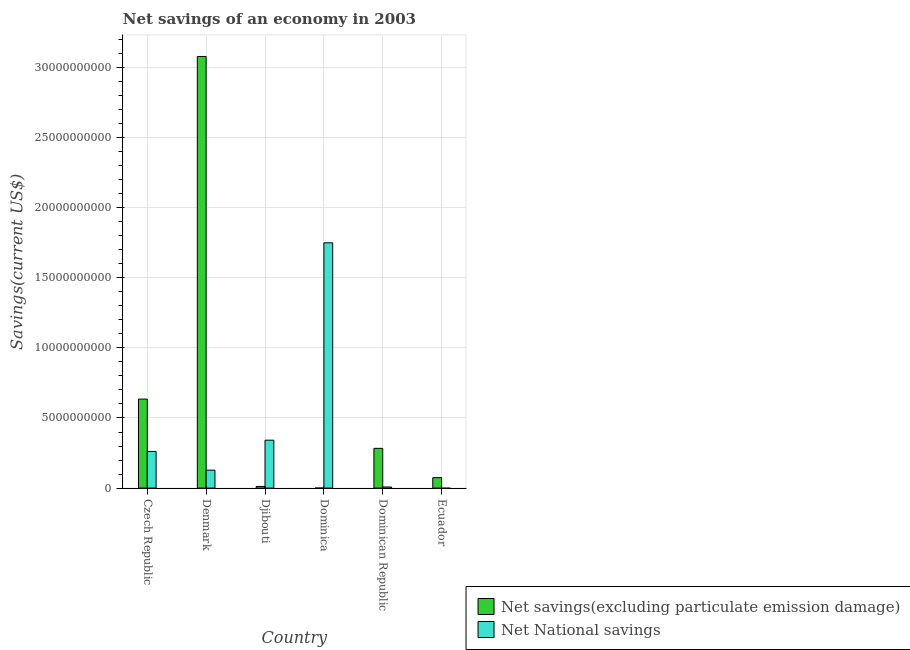How many different coloured bars are there?
Your answer should be very brief. 2. Are the number of bars on each tick of the X-axis equal?
Your answer should be compact. No. How many bars are there on the 6th tick from the left?
Give a very brief answer. 1. How many bars are there on the 5th tick from the right?
Give a very brief answer. 2. What is the label of the 5th group of bars from the left?
Make the answer very short. Dominican Republic. What is the net savings(excluding particulate emission damage) in Dominican Republic?
Your response must be concise. 2.84e+09. Across all countries, what is the maximum net savings(excluding particulate emission damage)?
Ensure brevity in your answer.  3.08e+1. In which country was the net national savings maximum?
Keep it short and to the point. Dominica. What is the total net savings(excluding particulate emission damage) in the graph?
Provide a succinct answer. 4.08e+1. What is the difference between the net savings(excluding particulate emission damage) in Djibouti and that in Dominica?
Your answer should be very brief. 1.18e+08. What is the difference between the net national savings in Ecuador and the net savings(excluding particulate emission damage) in Dominican Republic?
Make the answer very short. -2.84e+09. What is the average net national savings per country?
Your response must be concise. 4.15e+09. What is the difference between the net savings(excluding particulate emission damage) and net national savings in Dominican Republic?
Provide a short and direct response. 2.76e+09. What is the ratio of the net savings(excluding particulate emission damage) in Czech Republic to that in Denmark?
Make the answer very short. 0.21. What is the difference between the highest and the second highest net national savings?
Keep it short and to the point. 1.41e+1. What is the difference between the highest and the lowest net national savings?
Your answer should be very brief. 1.75e+1. In how many countries, is the net national savings greater than the average net national savings taken over all countries?
Offer a terse response. 1. Is the sum of the net savings(excluding particulate emission damage) in Czech Republic and Djibouti greater than the maximum net national savings across all countries?
Make the answer very short. No. Are the values on the major ticks of Y-axis written in scientific E-notation?
Your answer should be very brief. No. Does the graph contain any zero values?
Your answer should be compact. Yes. Does the graph contain grids?
Offer a terse response. Yes. How many legend labels are there?
Your answer should be very brief. 2. How are the legend labels stacked?
Give a very brief answer. Vertical. What is the title of the graph?
Give a very brief answer. Net savings of an economy in 2003. What is the label or title of the Y-axis?
Your response must be concise. Savings(current US$). What is the Savings(current US$) of Net savings(excluding particulate emission damage) in Czech Republic?
Offer a terse response. 6.35e+09. What is the Savings(current US$) in Net National savings in Czech Republic?
Your response must be concise. 2.61e+09. What is the Savings(current US$) in Net savings(excluding particulate emission damage) in Denmark?
Offer a terse response. 3.08e+1. What is the Savings(current US$) of Net National savings in Denmark?
Give a very brief answer. 1.28e+09. What is the Savings(current US$) in Net savings(excluding particulate emission damage) in Djibouti?
Your answer should be very brief. 1.19e+08. What is the Savings(current US$) in Net National savings in Djibouti?
Keep it short and to the point. 3.42e+09. What is the Savings(current US$) in Net savings(excluding particulate emission damage) in Dominica?
Give a very brief answer. 1.30e+06. What is the Savings(current US$) of Net National savings in Dominica?
Your answer should be very brief. 1.75e+1. What is the Savings(current US$) in Net savings(excluding particulate emission damage) in Dominican Republic?
Ensure brevity in your answer.  2.84e+09. What is the Savings(current US$) in Net National savings in Dominican Republic?
Provide a succinct answer. 7.85e+07. What is the Savings(current US$) of Net savings(excluding particulate emission damage) in Ecuador?
Make the answer very short. 7.47e+08. Across all countries, what is the maximum Savings(current US$) of Net savings(excluding particulate emission damage)?
Offer a terse response. 3.08e+1. Across all countries, what is the maximum Savings(current US$) in Net National savings?
Your answer should be compact. 1.75e+1. Across all countries, what is the minimum Savings(current US$) of Net savings(excluding particulate emission damage)?
Provide a short and direct response. 1.30e+06. What is the total Savings(current US$) in Net savings(excluding particulate emission damage) in the graph?
Your response must be concise. 4.08e+1. What is the total Savings(current US$) of Net National savings in the graph?
Provide a succinct answer. 2.49e+1. What is the difference between the Savings(current US$) of Net savings(excluding particulate emission damage) in Czech Republic and that in Denmark?
Your answer should be compact. -2.44e+1. What is the difference between the Savings(current US$) of Net National savings in Czech Republic and that in Denmark?
Provide a short and direct response. 1.33e+09. What is the difference between the Savings(current US$) of Net savings(excluding particulate emission damage) in Czech Republic and that in Djibouti?
Offer a terse response. 6.23e+09. What is the difference between the Savings(current US$) of Net National savings in Czech Republic and that in Djibouti?
Offer a very short reply. -8.05e+08. What is the difference between the Savings(current US$) in Net savings(excluding particulate emission damage) in Czech Republic and that in Dominica?
Make the answer very short. 6.35e+09. What is the difference between the Savings(current US$) of Net National savings in Czech Republic and that in Dominica?
Make the answer very short. -1.49e+1. What is the difference between the Savings(current US$) in Net savings(excluding particulate emission damage) in Czech Republic and that in Dominican Republic?
Keep it short and to the point. 3.51e+09. What is the difference between the Savings(current US$) of Net National savings in Czech Republic and that in Dominican Republic?
Your answer should be compact. 2.53e+09. What is the difference between the Savings(current US$) of Net savings(excluding particulate emission damage) in Czech Republic and that in Ecuador?
Offer a very short reply. 5.60e+09. What is the difference between the Savings(current US$) in Net savings(excluding particulate emission damage) in Denmark and that in Djibouti?
Provide a succinct answer. 3.07e+1. What is the difference between the Savings(current US$) in Net National savings in Denmark and that in Djibouti?
Give a very brief answer. -2.14e+09. What is the difference between the Savings(current US$) in Net savings(excluding particulate emission damage) in Denmark and that in Dominica?
Offer a very short reply. 3.08e+1. What is the difference between the Savings(current US$) of Net National savings in Denmark and that in Dominica?
Your answer should be compact. -1.62e+1. What is the difference between the Savings(current US$) in Net savings(excluding particulate emission damage) in Denmark and that in Dominican Republic?
Your answer should be very brief. 2.80e+1. What is the difference between the Savings(current US$) of Net National savings in Denmark and that in Dominican Republic?
Provide a short and direct response. 1.20e+09. What is the difference between the Savings(current US$) in Net savings(excluding particulate emission damage) in Denmark and that in Ecuador?
Offer a very short reply. 3.00e+1. What is the difference between the Savings(current US$) of Net savings(excluding particulate emission damage) in Djibouti and that in Dominica?
Offer a very short reply. 1.18e+08. What is the difference between the Savings(current US$) of Net National savings in Djibouti and that in Dominica?
Your answer should be very brief. -1.41e+1. What is the difference between the Savings(current US$) in Net savings(excluding particulate emission damage) in Djibouti and that in Dominican Republic?
Give a very brief answer. -2.72e+09. What is the difference between the Savings(current US$) of Net National savings in Djibouti and that in Dominican Republic?
Provide a short and direct response. 3.34e+09. What is the difference between the Savings(current US$) in Net savings(excluding particulate emission damage) in Djibouti and that in Ecuador?
Your answer should be compact. -6.28e+08. What is the difference between the Savings(current US$) of Net savings(excluding particulate emission damage) in Dominica and that in Dominican Republic?
Your answer should be very brief. -2.83e+09. What is the difference between the Savings(current US$) of Net National savings in Dominica and that in Dominican Republic?
Keep it short and to the point. 1.74e+1. What is the difference between the Savings(current US$) of Net savings(excluding particulate emission damage) in Dominica and that in Ecuador?
Provide a succinct answer. -7.45e+08. What is the difference between the Savings(current US$) of Net savings(excluding particulate emission damage) in Dominican Republic and that in Ecuador?
Provide a succinct answer. 2.09e+09. What is the difference between the Savings(current US$) of Net savings(excluding particulate emission damage) in Czech Republic and the Savings(current US$) of Net National savings in Denmark?
Ensure brevity in your answer.  5.07e+09. What is the difference between the Savings(current US$) in Net savings(excluding particulate emission damage) in Czech Republic and the Savings(current US$) in Net National savings in Djibouti?
Offer a very short reply. 2.93e+09. What is the difference between the Savings(current US$) in Net savings(excluding particulate emission damage) in Czech Republic and the Savings(current US$) in Net National savings in Dominica?
Your answer should be compact. -1.11e+1. What is the difference between the Savings(current US$) of Net savings(excluding particulate emission damage) in Czech Republic and the Savings(current US$) of Net National savings in Dominican Republic?
Keep it short and to the point. 6.27e+09. What is the difference between the Savings(current US$) in Net savings(excluding particulate emission damage) in Denmark and the Savings(current US$) in Net National savings in Djibouti?
Give a very brief answer. 2.74e+1. What is the difference between the Savings(current US$) of Net savings(excluding particulate emission damage) in Denmark and the Savings(current US$) of Net National savings in Dominica?
Give a very brief answer. 1.33e+1. What is the difference between the Savings(current US$) of Net savings(excluding particulate emission damage) in Denmark and the Savings(current US$) of Net National savings in Dominican Republic?
Provide a succinct answer. 3.07e+1. What is the difference between the Savings(current US$) of Net savings(excluding particulate emission damage) in Djibouti and the Savings(current US$) of Net National savings in Dominica?
Provide a succinct answer. -1.74e+1. What is the difference between the Savings(current US$) in Net savings(excluding particulate emission damage) in Djibouti and the Savings(current US$) in Net National savings in Dominican Republic?
Your response must be concise. 4.05e+07. What is the difference between the Savings(current US$) of Net savings(excluding particulate emission damage) in Dominica and the Savings(current US$) of Net National savings in Dominican Republic?
Provide a succinct answer. -7.72e+07. What is the average Savings(current US$) in Net savings(excluding particulate emission damage) per country?
Your answer should be very brief. 6.81e+09. What is the average Savings(current US$) of Net National savings per country?
Provide a short and direct response. 4.15e+09. What is the difference between the Savings(current US$) in Net savings(excluding particulate emission damage) and Savings(current US$) in Net National savings in Czech Republic?
Your answer should be very brief. 3.74e+09. What is the difference between the Savings(current US$) of Net savings(excluding particulate emission damage) and Savings(current US$) of Net National savings in Denmark?
Provide a succinct answer. 2.95e+1. What is the difference between the Savings(current US$) in Net savings(excluding particulate emission damage) and Savings(current US$) in Net National savings in Djibouti?
Give a very brief answer. -3.30e+09. What is the difference between the Savings(current US$) of Net savings(excluding particulate emission damage) and Savings(current US$) of Net National savings in Dominica?
Your response must be concise. -1.75e+1. What is the difference between the Savings(current US$) in Net savings(excluding particulate emission damage) and Savings(current US$) in Net National savings in Dominican Republic?
Provide a short and direct response. 2.76e+09. What is the ratio of the Savings(current US$) of Net savings(excluding particulate emission damage) in Czech Republic to that in Denmark?
Ensure brevity in your answer.  0.21. What is the ratio of the Savings(current US$) in Net National savings in Czech Republic to that in Denmark?
Your response must be concise. 2.04. What is the ratio of the Savings(current US$) of Net savings(excluding particulate emission damage) in Czech Republic to that in Djibouti?
Your response must be concise. 53.34. What is the ratio of the Savings(current US$) in Net National savings in Czech Republic to that in Djibouti?
Keep it short and to the point. 0.76. What is the ratio of the Savings(current US$) in Net savings(excluding particulate emission damage) in Czech Republic to that in Dominica?
Ensure brevity in your answer.  4875.76. What is the ratio of the Savings(current US$) of Net National savings in Czech Republic to that in Dominica?
Your answer should be compact. 0.15. What is the ratio of the Savings(current US$) of Net savings(excluding particulate emission damage) in Czech Republic to that in Dominican Republic?
Make the answer very short. 2.24. What is the ratio of the Savings(current US$) in Net National savings in Czech Republic to that in Dominican Republic?
Your response must be concise. 33.25. What is the ratio of the Savings(current US$) of Net savings(excluding particulate emission damage) in Czech Republic to that in Ecuador?
Your answer should be compact. 8.5. What is the ratio of the Savings(current US$) in Net savings(excluding particulate emission damage) in Denmark to that in Djibouti?
Ensure brevity in your answer.  258.66. What is the ratio of the Savings(current US$) in Net National savings in Denmark to that in Djibouti?
Give a very brief answer. 0.37. What is the ratio of the Savings(current US$) in Net savings(excluding particulate emission damage) in Denmark to that in Dominica?
Ensure brevity in your answer.  2.36e+04. What is the ratio of the Savings(current US$) in Net National savings in Denmark to that in Dominica?
Keep it short and to the point. 0.07. What is the ratio of the Savings(current US$) in Net savings(excluding particulate emission damage) in Denmark to that in Dominican Republic?
Your answer should be very brief. 10.86. What is the ratio of the Savings(current US$) in Net National savings in Denmark to that in Dominican Republic?
Offer a very short reply. 16.28. What is the ratio of the Savings(current US$) in Net savings(excluding particulate emission damage) in Denmark to that in Ecuador?
Keep it short and to the point. 41.24. What is the ratio of the Savings(current US$) of Net savings(excluding particulate emission damage) in Djibouti to that in Dominica?
Give a very brief answer. 91.42. What is the ratio of the Savings(current US$) in Net National savings in Djibouti to that in Dominica?
Your answer should be compact. 0.2. What is the ratio of the Savings(current US$) in Net savings(excluding particulate emission damage) in Djibouti to that in Dominican Republic?
Your response must be concise. 0.04. What is the ratio of the Savings(current US$) of Net National savings in Djibouti to that in Dominican Republic?
Offer a terse response. 43.51. What is the ratio of the Savings(current US$) in Net savings(excluding particulate emission damage) in Djibouti to that in Ecuador?
Ensure brevity in your answer.  0.16. What is the ratio of the Savings(current US$) in Net National savings in Dominica to that in Dominican Republic?
Ensure brevity in your answer.  222.77. What is the ratio of the Savings(current US$) of Net savings(excluding particulate emission damage) in Dominica to that in Ecuador?
Ensure brevity in your answer.  0. What is the ratio of the Savings(current US$) of Net savings(excluding particulate emission damage) in Dominican Republic to that in Ecuador?
Keep it short and to the point. 3.8. What is the difference between the highest and the second highest Savings(current US$) in Net savings(excluding particulate emission damage)?
Your answer should be very brief. 2.44e+1. What is the difference between the highest and the second highest Savings(current US$) of Net National savings?
Provide a succinct answer. 1.41e+1. What is the difference between the highest and the lowest Savings(current US$) in Net savings(excluding particulate emission damage)?
Offer a terse response. 3.08e+1. What is the difference between the highest and the lowest Savings(current US$) in Net National savings?
Keep it short and to the point. 1.75e+1. 